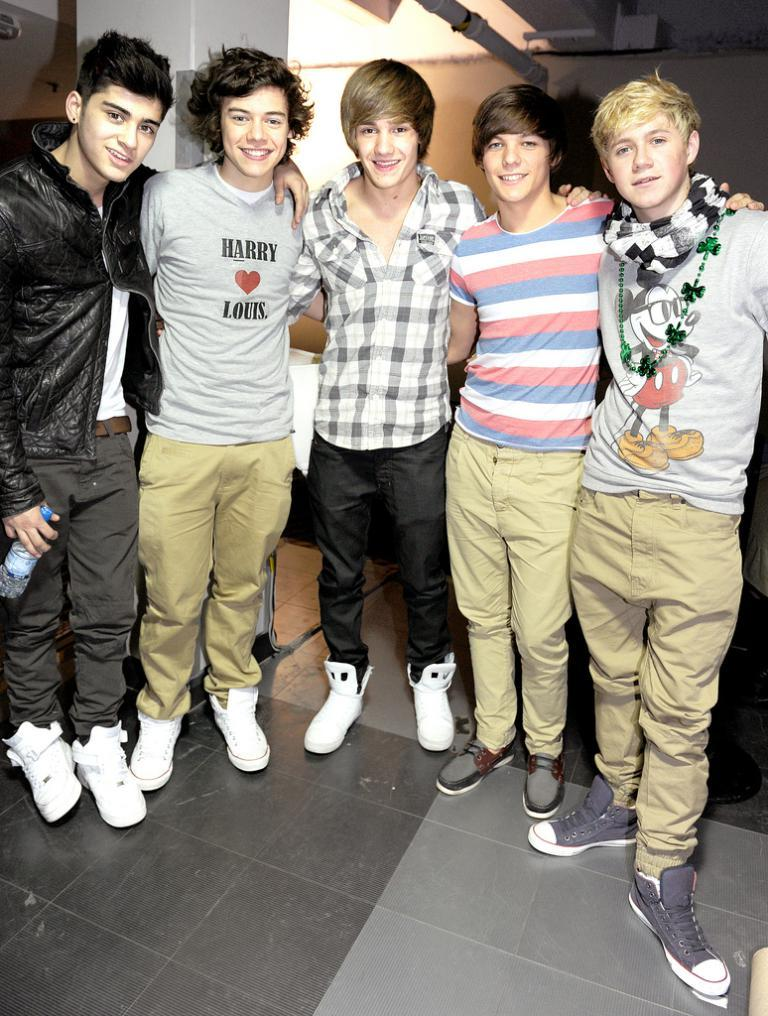How many people are in the image? There is a group of five people in the image. What are the people doing in the image? The people are standing. What can be seen in the background of the image? There is a wall in the background of the image. What color is the crayon used by the people in the image? There is no crayon present in the image. 